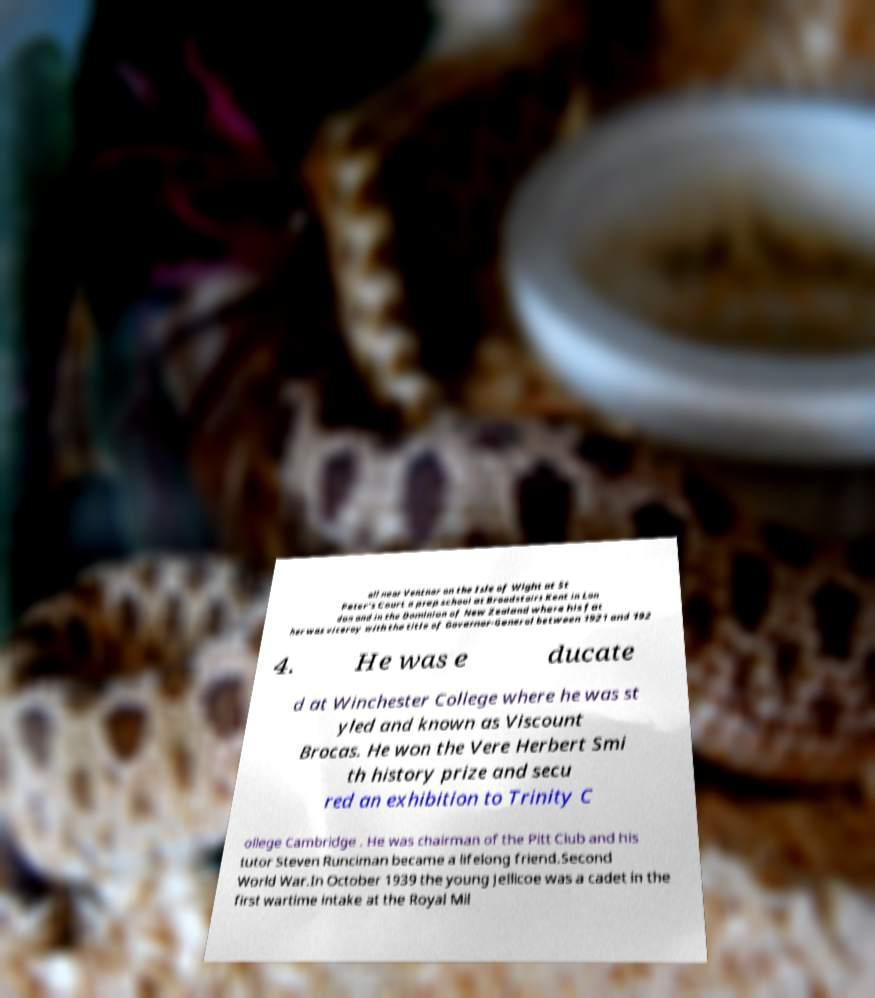Can you accurately transcribe the text from the provided image for me? all near Ventnor on the Isle of Wight at St Peter's Court a prep school at Broadstairs Kent in Lon don and in the Dominion of New Zealand where his fat her was viceroy with the title of Governor-General between 1921 and 192 4. He was e ducate d at Winchester College where he was st yled and known as Viscount Brocas. He won the Vere Herbert Smi th history prize and secu red an exhibition to Trinity C ollege Cambridge . He was chairman of the Pitt Club and his tutor Steven Runciman became a lifelong friend.Second World War.In October 1939 the young Jellicoe was a cadet in the first wartime intake at the Royal Mil 